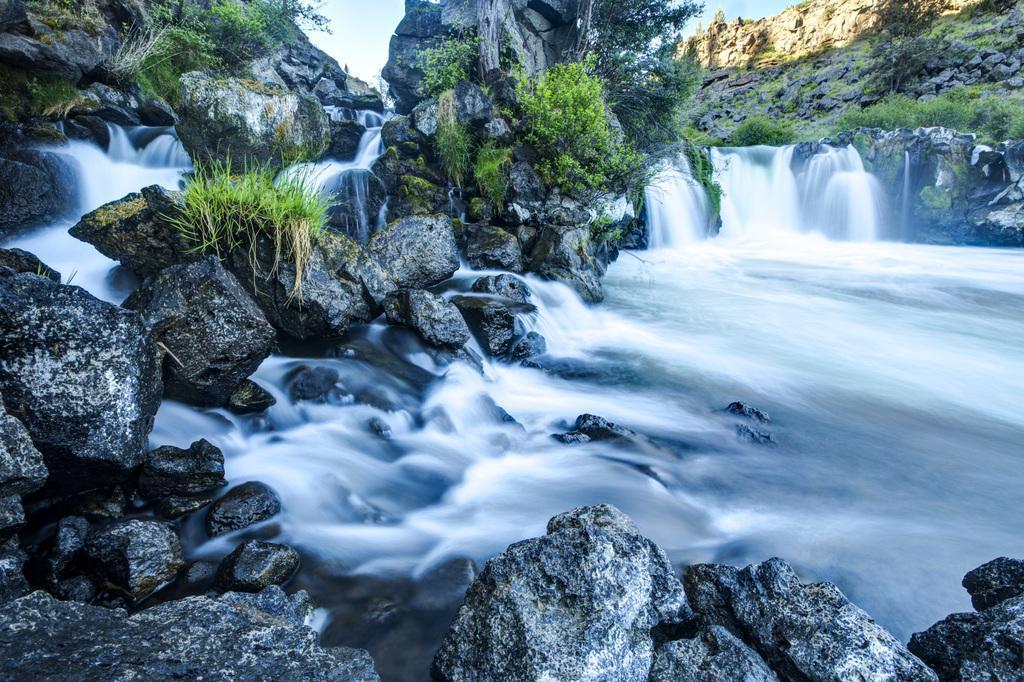How would you summarize this image in a sentence or two? In this image there are rocky mountains. On the mountains there are plants and grass. There are waterfalls on the mountains. To the right there is water flowing. At the top there is the sky. 